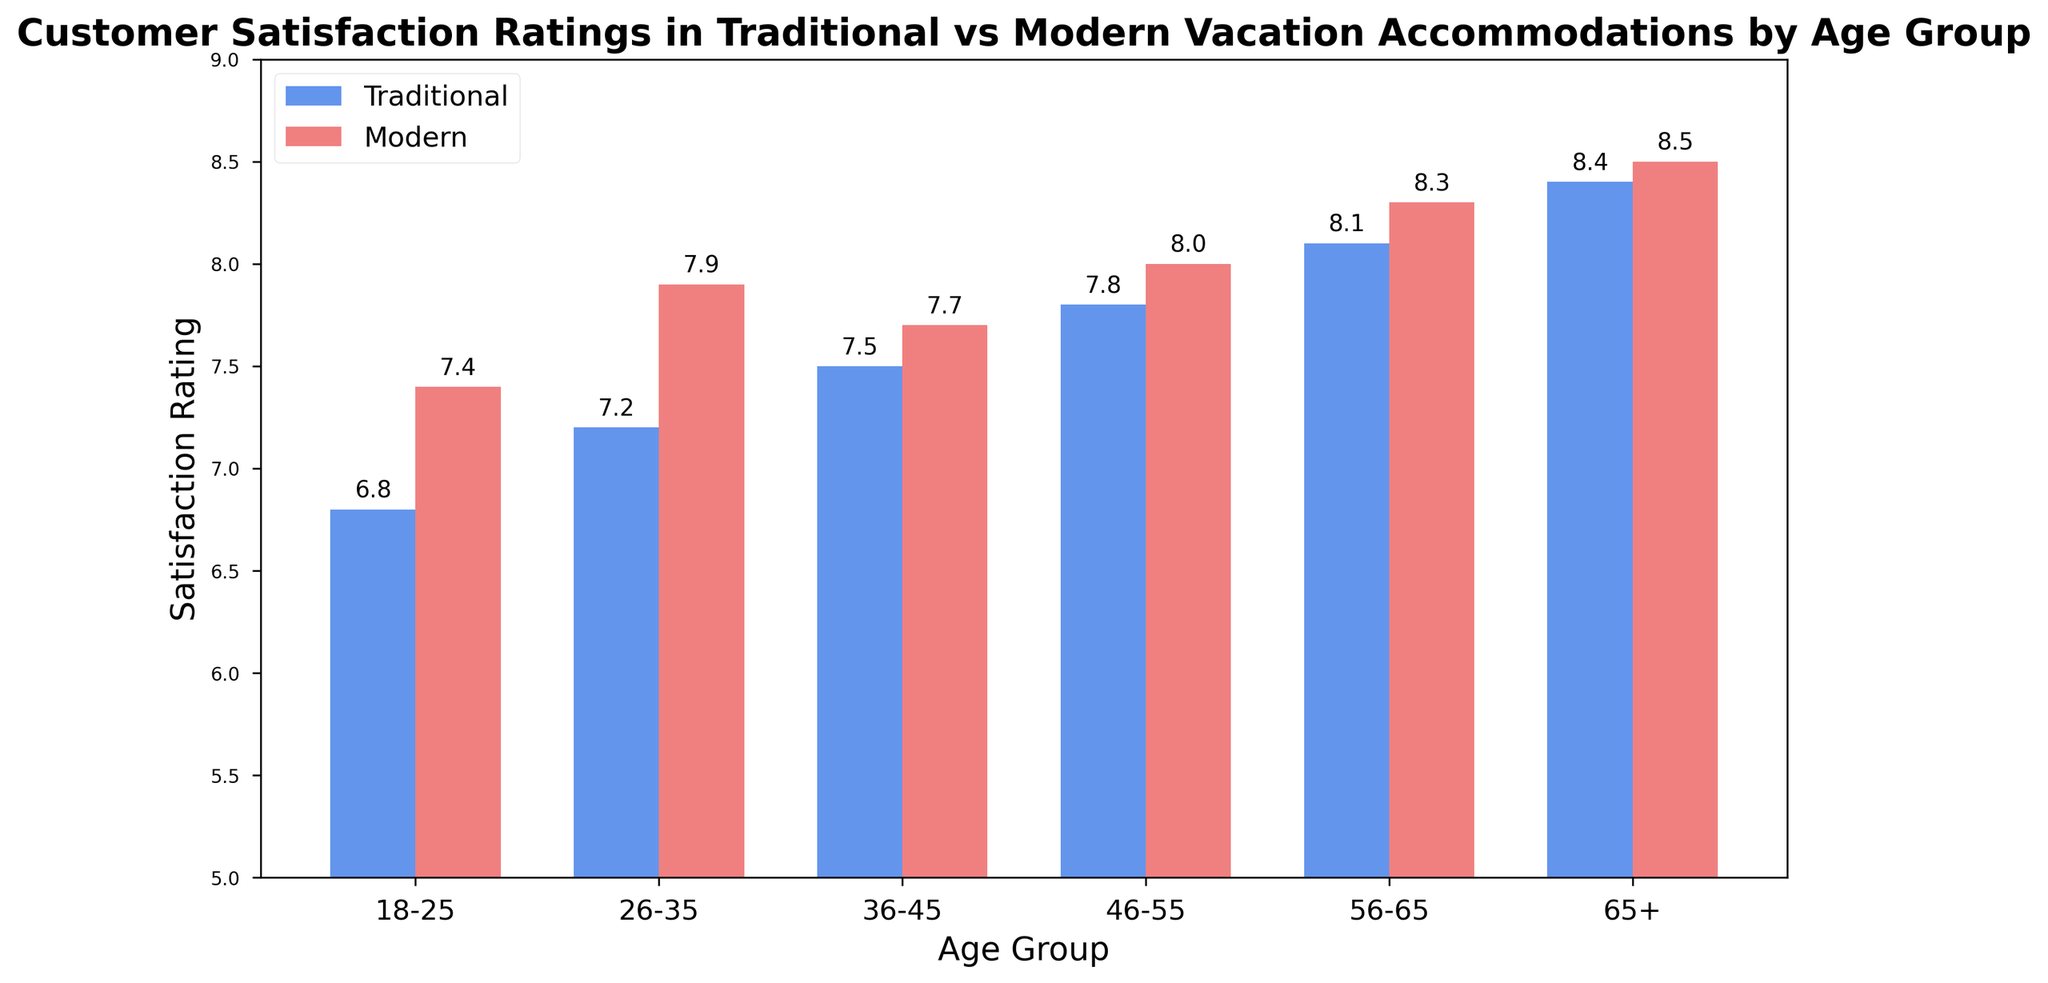What is the satisfaction rating for the age group 18-25 in traditional accommodation? The value for traditional accommodation in the age group 18-25 is indicated by the height of the blue bar next to the label '18-25'.
Answer: 6.8 How much higher is the satisfaction rating for modern accommodation compared to traditional accommodation for the age group 26-35? The satisfaction rating for traditional accommodation is 7.2, and for modern accommodation, it is 7.9. Subtract the former from the latter: 7.9 - 7.2.
Answer: 0.7 What is the average satisfaction rating across all age groups for modern accommodations? The ratings for modern accommodations across age groups are: 7.4, 7.9, 7.7, 8.0, 8.3, and 8.5. The sum of these values is 48.8. There are 6 age groups, so 48.8/6.
Answer: 8.13 Which age group has the highest satisfaction rating for traditional accommodations and what is the value? The highest satisfaction rating for traditional accommodations is represented by the highest blue bar. The age group of this highest bar is 65+ with a value of 8.4.
Answer: 65+, 8.4 Summarize the trends in satisfaction ratings for modern vs. traditional accommodation across all age groups. By visually examining the heights of the bars, it can be observed that the satisfaction rating generally increases with age for both types of accommodation. However, modern accommodations consistently have higher ratings than traditional accommodations within each age group.
Answer: Ratings increase with age, modern is consistently higher What's the range of satisfaction ratings for traditional accommodations across all age groups? The minimum satisfaction rating is 6.8 (age group 18-25), and the maximum is 8.4 (age group 65+). The difference between the maximum and minimum values is 8.4 - 6.8.
Answer: 1.6 